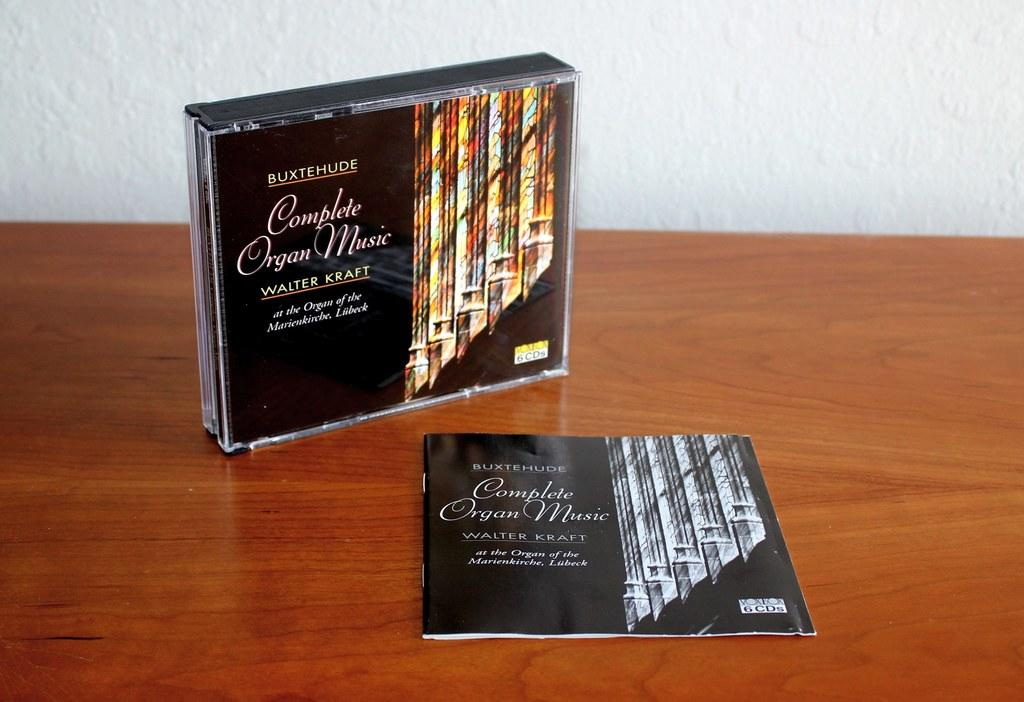<image>
Summarize the visual content of the image. The CD case and insert book for Complete Organ Music by Walter Kraft both sitting on a table. 